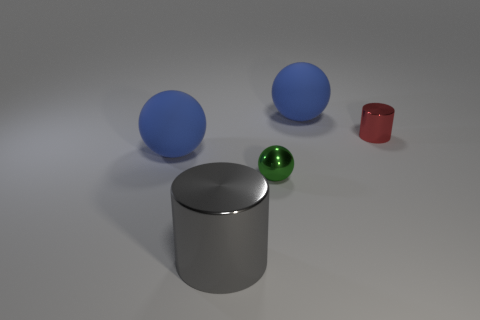There is a big gray object; does it have the same shape as the red object that is behind the big cylinder?
Keep it short and to the point. Yes. How big is the green metal sphere?
Ensure brevity in your answer.  Small. Are there fewer tiny metal things in front of the small green shiny sphere than cyan balls?
Make the answer very short. No. How many other yellow metal spheres are the same size as the metallic sphere?
Make the answer very short. 0. Do the large ball that is behind the tiny cylinder and the sphere left of the big gray object have the same color?
Make the answer very short. Yes. How many big matte things are in front of the red object?
Provide a short and direct response. 1. Is there a gray thing of the same shape as the red object?
Provide a short and direct response. Yes. There is a shiny ball that is the same size as the red metallic cylinder; what is its color?
Offer a very short reply. Green. Is the number of big blue spheres that are on the left side of the tiny metal ball less than the number of large gray cylinders on the left side of the large gray object?
Make the answer very short. No. Is the size of the blue matte thing that is behind the red shiny object the same as the tiny red thing?
Provide a succinct answer. No. 